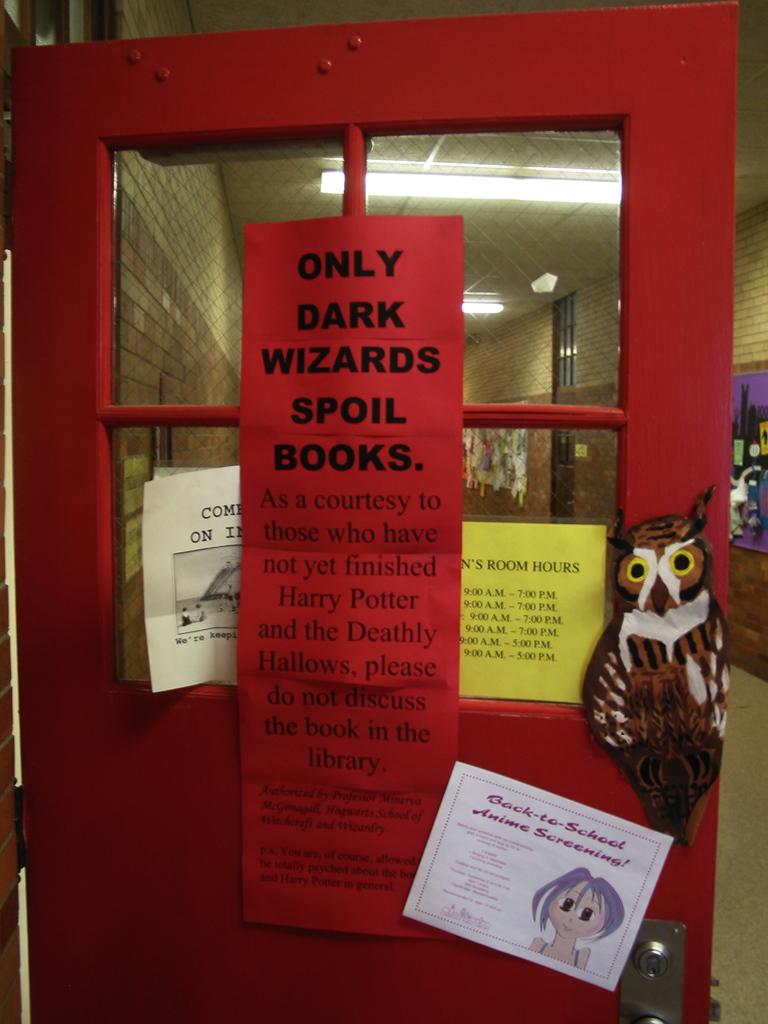Provide a one-sentence caption for the provided image. Inside of a school hallway with a red door opened with a cut out of a sticker and a sign say only dark wizards spoil books. 